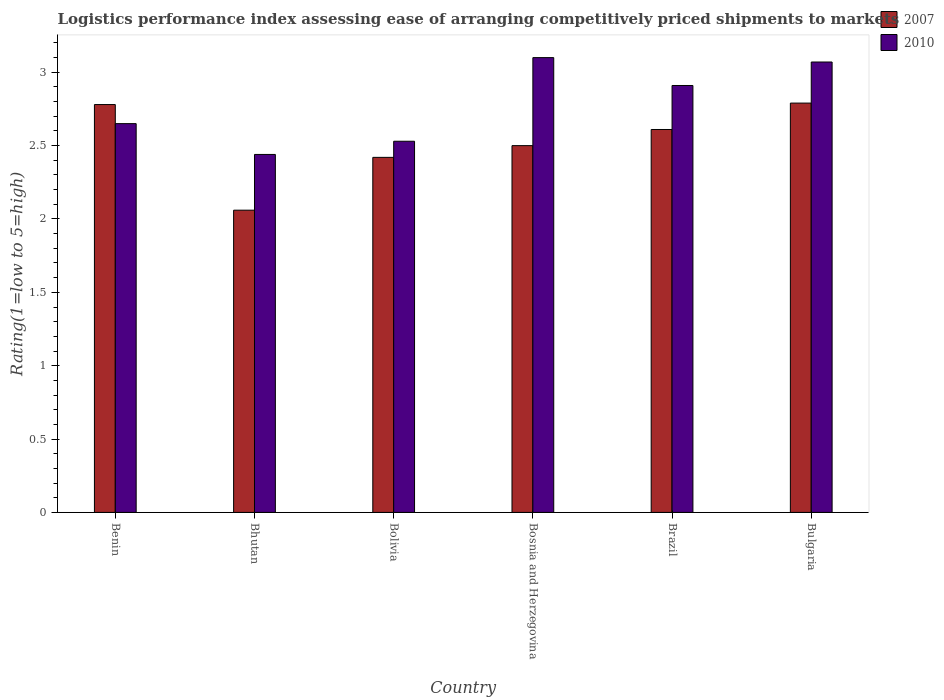How many different coloured bars are there?
Ensure brevity in your answer.  2. Are the number of bars per tick equal to the number of legend labels?
Provide a succinct answer. Yes. What is the label of the 4th group of bars from the left?
Keep it short and to the point. Bosnia and Herzegovina. What is the Logistic performance index in 2007 in Bulgaria?
Ensure brevity in your answer.  2.79. Across all countries, what is the minimum Logistic performance index in 2010?
Ensure brevity in your answer.  2.44. In which country was the Logistic performance index in 2010 maximum?
Your response must be concise. Bosnia and Herzegovina. In which country was the Logistic performance index in 2007 minimum?
Make the answer very short. Bhutan. What is the difference between the Logistic performance index in 2010 in Bhutan and that in Bulgaria?
Your answer should be compact. -0.63. What is the difference between the Logistic performance index in 2010 in Bhutan and the Logistic performance index in 2007 in Bosnia and Herzegovina?
Give a very brief answer. -0.06. What is the average Logistic performance index in 2010 per country?
Make the answer very short. 2.78. What is the difference between the Logistic performance index of/in 2010 and Logistic performance index of/in 2007 in Brazil?
Make the answer very short. 0.3. In how many countries, is the Logistic performance index in 2007 greater than 2.1?
Your response must be concise. 5. What is the ratio of the Logistic performance index in 2010 in Bolivia to that in Bulgaria?
Provide a short and direct response. 0.82. What is the difference between the highest and the second highest Logistic performance index in 2010?
Offer a very short reply. 0.16. What is the difference between the highest and the lowest Logistic performance index in 2007?
Your response must be concise. 0.73. In how many countries, is the Logistic performance index in 2007 greater than the average Logistic performance index in 2007 taken over all countries?
Your answer should be compact. 3. Is the sum of the Logistic performance index in 2007 in Bhutan and Bulgaria greater than the maximum Logistic performance index in 2010 across all countries?
Offer a terse response. Yes. What does the 2nd bar from the left in Brazil represents?
Your answer should be compact. 2010. What does the 1st bar from the right in Bulgaria represents?
Make the answer very short. 2010. How many bars are there?
Keep it short and to the point. 12. How many countries are there in the graph?
Provide a succinct answer. 6. What is the difference between two consecutive major ticks on the Y-axis?
Offer a very short reply. 0.5. Are the values on the major ticks of Y-axis written in scientific E-notation?
Your response must be concise. No. Does the graph contain grids?
Ensure brevity in your answer.  No. Where does the legend appear in the graph?
Offer a terse response. Top right. How many legend labels are there?
Provide a succinct answer. 2. What is the title of the graph?
Ensure brevity in your answer.  Logistics performance index assessing ease of arranging competitively priced shipments to markets. Does "1966" appear as one of the legend labels in the graph?
Ensure brevity in your answer.  No. What is the label or title of the X-axis?
Provide a succinct answer. Country. What is the label or title of the Y-axis?
Offer a terse response. Rating(1=low to 5=high). What is the Rating(1=low to 5=high) in 2007 in Benin?
Keep it short and to the point. 2.78. What is the Rating(1=low to 5=high) in 2010 in Benin?
Offer a very short reply. 2.65. What is the Rating(1=low to 5=high) of 2007 in Bhutan?
Give a very brief answer. 2.06. What is the Rating(1=low to 5=high) in 2010 in Bhutan?
Give a very brief answer. 2.44. What is the Rating(1=low to 5=high) of 2007 in Bolivia?
Provide a succinct answer. 2.42. What is the Rating(1=low to 5=high) of 2010 in Bolivia?
Keep it short and to the point. 2.53. What is the Rating(1=low to 5=high) in 2007 in Bosnia and Herzegovina?
Provide a short and direct response. 2.5. What is the Rating(1=low to 5=high) of 2010 in Bosnia and Herzegovina?
Provide a short and direct response. 3.1. What is the Rating(1=low to 5=high) of 2007 in Brazil?
Keep it short and to the point. 2.61. What is the Rating(1=low to 5=high) of 2010 in Brazil?
Your answer should be compact. 2.91. What is the Rating(1=low to 5=high) of 2007 in Bulgaria?
Give a very brief answer. 2.79. What is the Rating(1=low to 5=high) in 2010 in Bulgaria?
Provide a short and direct response. 3.07. Across all countries, what is the maximum Rating(1=low to 5=high) in 2007?
Provide a short and direct response. 2.79. Across all countries, what is the minimum Rating(1=low to 5=high) in 2007?
Provide a short and direct response. 2.06. Across all countries, what is the minimum Rating(1=low to 5=high) of 2010?
Provide a succinct answer. 2.44. What is the total Rating(1=low to 5=high) of 2007 in the graph?
Provide a succinct answer. 15.16. What is the total Rating(1=low to 5=high) in 2010 in the graph?
Make the answer very short. 16.7. What is the difference between the Rating(1=low to 5=high) of 2007 in Benin and that in Bhutan?
Provide a succinct answer. 0.72. What is the difference between the Rating(1=low to 5=high) in 2010 in Benin and that in Bhutan?
Make the answer very short. 0.21. What is the difference between the Rating(1=low to 5=high) in 2007 in Benin and that in Bolivia?
Ensure brevity in your answer.  0.36. What is the difference between the Rating(1=low to 5=high) of 2010 in Benin and that in Bolivia?
Provide a short and direct response. 0.12. What is the difference between the Rating(1=low to 5=high) in 2007 in Benin and that in Bosnia and Herzegovina?
Provide a short and direct response. 0.28. What is the difference between the Rating(1=low to 5=high) of 2010 in Benin and that in Bosnia and Herzegovina?
Your response must be concise. -0.45. What is the difference between the Rating(1=low to 5=high) of 2007 in Benin and that in Brazil?
Make the answer very short. 0.17. What is the difference between the Rating(1=low to 5=high) in 2010 in Benin and that in Brazil?
Keep it short and to the point. -0.26. What is the difference between the Rating(1=low to 5=high) of 2007 in Benin and that in Bulgaria?
Ensure brevity in your answer.  -0.01. What is the difference between the Rating(1=low to 5=high) of 2010 in Benin and that in Bulgaria?
Your answer should be compact. -0.42. What is the difference between the Rating(1=low to 5=high) in 2007 in Bhutan and that in Bolivia?
Make the answer very short. -0.36. What is the difference between the Rating(1=low to 5=high) in 2010 in Bhutan and that in Bolivia?
Your response must be concise. -0.09. What is the difference between the Rating(1=low to 5=high) of 2007 in Bhutan and that in Bosnia and Herzegovina?
Ensure brevity in your answer.  -0.44. What is the difference between the Rating(1=low to 5=high) of 2010 in Bhutan and that in Bosnia and Herzegovina?
Your response must be concise. -0.66. What is the difference between the Rating(1=low to 5=high) of 2007 in Bhutan and that in Brazil?
Provide a short and direct response. -0.55. What is the difference between the Rating(1=low to 5=high) of 2010 in Bhutan and that in Brazil?
Provide a short and direct response. -0.47. What is the difference between the Rating(1=low to 5=high) in 2007 in Bhutan and that in Bulgaria?
Your answer should be very brief. -0.73. What is the difference between the Rating(1=low to 5=high) of 2010 in Bhutan and that in Bulgaria?
Give a very brief answer. -0.63. What is the difference between the Rating(1=low to 5=high) in 2007 in Bolivia and that in Bosnia and Herzegovina?
Your answer should be compact. -0.08. What is the difference between the Rating(1=low to 5=high) of 2010 in Bolivia and that in Bosnia and Herzegovina?
Make the answer very short. -0.57. What is the difference between the Rating(1=low to 5=high) in 2007 in Bolivia and that in Brazil?
Provide a short and direct response. -0.19. What is the difference between the Rating(1=low to 5=high) of 2010 in Bolivia and that in Brazil?
Offer a very short reply. -0.38. What is the difference between the Rating(1=low to 5=high) of 2007 in Bolivia and that in Bulgaria?
Provide a succinct answer. -0.37. What is the difference between the Rating(1=low to 5=high) of 2010 in Bolivia and that in Bulgaria?
Keep it short and to the point. -0.54. What is the difference between the Rating(1=low to 5=high) of 2007 in Bosnia and Herzegovina and that in Brazil?
Offer a terse response. -0.11. What is the difference between the Rating(1=low to 5=high) in 2010 in Bosnia and Herzegovina and that in Brazil?
Your answer should be compact. 0.19. What is the difference between the Rating(1=low to 5=high) of 2007 in Bosnia and Herzegovina and that in Bulgaria?
Provide a succinct answer. -0.29. What is the difference between the Rating(1=low to 5=high) in 2010 in Bosnia and Herzegovina and that in Bulgaria?
Give a very brief answer. 0.03. What is the difference between the Rating(1=low to 5=high) of 2007 in Brazil and that in Bulgaria?
Keep it short and to the point. -0.18. What is the difference between the Rating(1=low to 5=high) of 2010 in Brazil and that in Bulgaria?
Give a very brief answer. -0.16. What is the difference between the Rating(1=low to 5=high) in 2007 in Benin and the Rating(1=low to 5=high) in 2010 in Bhutan?
Your response must be concise. 0.34. What is the difference between the Rating(1=low to 5=high) in 2007 in Benin and the Rating(1=low to 5=high) in 2010 in Bolivia?
Your answer should be very brief. 0.25. What is the difference between the Rating(1=low to 5=high) of 2007 in Benin and the Rating(1=low to 5=high) of 2010 in Bosnia and Herzegovina?
Provide a succinct answer. -0.32. What is the difference between the Rating(1=low to 5=high) in 2007 in Benin and the Rating(1=low to 5=high) in 2010 in Brazil?
Your answer should be compact. -0.13. What is the difference between the Rating(1=low to 5=high) of 2007 in Benin and the Rating(1=low to 5=high) of 2010 in Bulgaria?
Your response must be concise. -0.29. What is the difference between the Rating(1=low to 5=high) in 2007 in Bhutan and the Rating(1=low to 5=high) in 2010 in Bolivia?
Keep it short and to the point. -0.47. What is the difference between the Rating(1=low to 5=high) of 2007 in Bhutan and the Rating(1=low to 5=high) of 2010 in Bosnia and Herzegovina?
Ensure brevity in your answer.  -1.04. What is the difference between the Rating(1=low to 5=high) of 2007 in Bhutan and the Rating(1=low to 5=high) of 2010 in Brazil?
Ensure brevity in your answer.  -0.85. What is the difference between the Rating(1=low to 5=high) of 2007 in Bhutan and the Rating(1=low to 5=high) of 2010 in Bulgaria?
Ensure brevity in your answer.  -1.01. What is the difference between the Rating(1=low to 5=high) in 2007 in Bolivia and the Rating(1=low to 5=high) in 2010 in Bosnia and Herzegovina?
Offer a very short reply. -0.68. What is the difference between the Rating(1=low to 5=high) of 2007 in Bolivia and the Rating(1=low to 5=high) of 2010 in Brazil?
Offer a very short reply. -0.49. What is the difference between the Rating(1=low to 5=high) of 2007 in Bolivia and the Rating(1=low to 5=high) of 2010 in Bulgaria?
Keep it short and to the point. -0.65. What is the difference between the Rating(1=low to 5=high) in 2007 in Bosnia and Herzegovina and the Rating(1=low to 5=high) in 2010 in Brazil?
Your answer should be very brief. -0.41. What is the difference between the Rating(1=low to 5=high) of 2007 in Bosnia and Herzegovina and the Rating(1=low to 5=high) of 2010 in Bulgaria?
Provide a short and direct response. -0.57. What is the difference between the Rating(1=low to 5=high) in 2007 in Brazil and the Rating(1=low to 5=high) in 2010 in Bulgaria?
Make the answer very short. -0.46. What is the average Rating(1=low to 5=high) of 2007 per country?
Ensure brevity in your answer.  2.53. What is the average Rating(1=low to 5=high) of 2010 per country?
Give a very brief answer. 2.78. What is the difference between the Rating(1=low to 5=high) in 2007 and Rating(1=low to 5=high) in 2010 in Benin?
Offer a terse response. 0.13. What is the difference between the Rating(1=low to 5=high) of 2007 and Rating(1=low to 5=high) of 2010 in Bhutan?
Your answer should be compact. -0.38. What is the difference between the Rating(1=low to 5=high) of 2007 and Rating(1=low to 5=high) of 2010 in Bolivia?
Your answer should be compact. -0.11. What is the difference between the Rating(1=low to 5=high) in 2007 and Rating(1=low to 5=high) in 2010 in Bosnia and Herzegovina?
Keep it short and to the point. -0.6. What is the difference between the Rating(1=low to 5=high) of 2007 and Rating(1=low to 5=high) of 2010 in Bulgaria?
Offer a terse response. -0.28. What is the ratio of the Rating(1=low to 5=high) in 2007 in Benin to that in Bhutan?
Provide a short and direct response. 1.35. What is the ratio of the Rating(1=low to 5=high) in 2010 in Benin to that in Bhutan?
Offer a terse response. 1.09. What is the ratio of the Rating(1=low to 5=high) of 2007 in Benin to that in Bolivia?
Provide a succinct answer. 1.15. What is the ratio of the Rating(1=low to 5=high) of 2010 in Benin to that in Bolivia?
Provide a short and direct response. 1.05. What is the ratio of the Rating(1=low to 5=high) of 2007 in Benin to that in Bosnia and Herzegovina?
Provide a succinct answer. 1.11. What is the ratio of the Rating(1=low to 5=high) of 2010 in Benin to that in Bosnia and Herzegovina?
Keep it short and to the point. 0.85. What is the ratio of the Rating(1=low to 5=high) of 2007 in Benin to that in Brazil?
Provide a succinct answer. 1.07. What is the ratio of the Rating(1=low to 5=high) in 2010 in Benin to that in Brazil?
Offer a very short reply. 0.91. What is the ratio of the Rating(1=low to 5=high) in 2007 in Benin to that in Bulgaria?
Your answer should be compact. 1. What is the ratio of the Rating(1=low to 5=high) of 2010 in Benin to that in Bulgaria?
Offer a terse response. 0.86. What is the ratio of the Rating(1=low to 5=high) in 2007 in Bhutan to that in Bolivia?
Provide a short and direct response. 0.85. What is the ratio of the Rating(1=low to 5=high) of 2010 in Bhutan to that in Bolivia?
Offer a very short reply. 0.96. What is the ratio of the Rating(1=low to 5=high) in 2007 in Bhutan to that in Bosnia and Herzegovina?
Give a very brief answer. 0.82. What is the ratio of the Rating(1=low to 5=high) of 2010 in Bhutan to that in Bosnia and Herzegovina?
Offer a very short reply. 0.79. What is the ratio of the Rating(1=low to 5=high) in 2007 in Bhutan to that in Brazil?
Your answer should be compact. 0.79. What is the ratio of the Rating(1=low to 5=high) of 2010 in Bhutan to that in Brazil?
Offer a terse response. 0.84. What is the ratio of the Rating(1=low to 5=high) of 2007 in Bhutan to that in Bulgaria?
Offer a very short reply. 0.74. What is the ratio of the Rating(1=low to 5=high) of 2010 in Bhutan to that in Bulgaria?
Offer a very short reply. 0.79. What is the ratio of the Rating(1=low to 5=high) of 2010 in Bolivia to that in Bosnia and Herzegovina?
Provide a succinct answer. 0.82. What is the ratio of the Rating(1=low to 5=high) in 2007 in Bolivia to that in Brazil?
Make the answer very short. 0.93. What is the ratio of the Rating(1=low to 5=high) in 2010 in Bolivia to that in Brazil?
Your response must be concise. 0.87. What is the ratio of the Rating(1=low to 5=high) in 2007 in Bolivia to that in Bulgaria?
Your response must be concise. 0.87. What is the ratio of the Rating(1=low to 5=high) of 2010 in Bolivia to that in Bulgaria?
Give a very brief answer. 0.82. What is the ratio of the Rating(1=low to 5=high) in 2007 in Bosnia and Herzegovina to that in Brazil?
Your response must be concise. 0.96. What is the ratio of the Rating(1=low to 5=high) of 2010 in Bosnia and Herzegovina to that in Brazil?
Your answer should be very brief. 1.07. What is the ratio of the Rating(1=low to 5=high) in 2007 in Bosnia and Herzegovina to that in Bulgaria?
Provide a short and direct response. 0.9. What is the ratio of the Rating(1=low to 5=high) in 2010 in Bosnia and Herzegovina to that in Bulgaria?
Keep it short and to the point. 1.01. What is the ratio of the Rating(1=low to 5=high) of 2007 in Brazil to that in Bulgaria?
Provide a short and direct response. 0.94. What is the ratio of the Rating(1=low to 5=high) in 2010 in Brazil to that in Bulgaria?
Give a very brief answer. 0.95. What is the difference between the highest and the second highest Rating(1=low to 5=high) of 2007?
Provide a succinct answer. 0.01. What is the difference between the highest and the second highest Rating(1=low to 5=high) in 2010?
Your response must be concise. 0.03. What is the difference between the highest and the lowest Rating(1=low to 5=high) in 2007?
Ensure brevity in your answer.  0.73. What is the difference between the highest and the lowest Rating(1=low to 5=high) in 2010?
Keep it short and to the point. 0.66. 